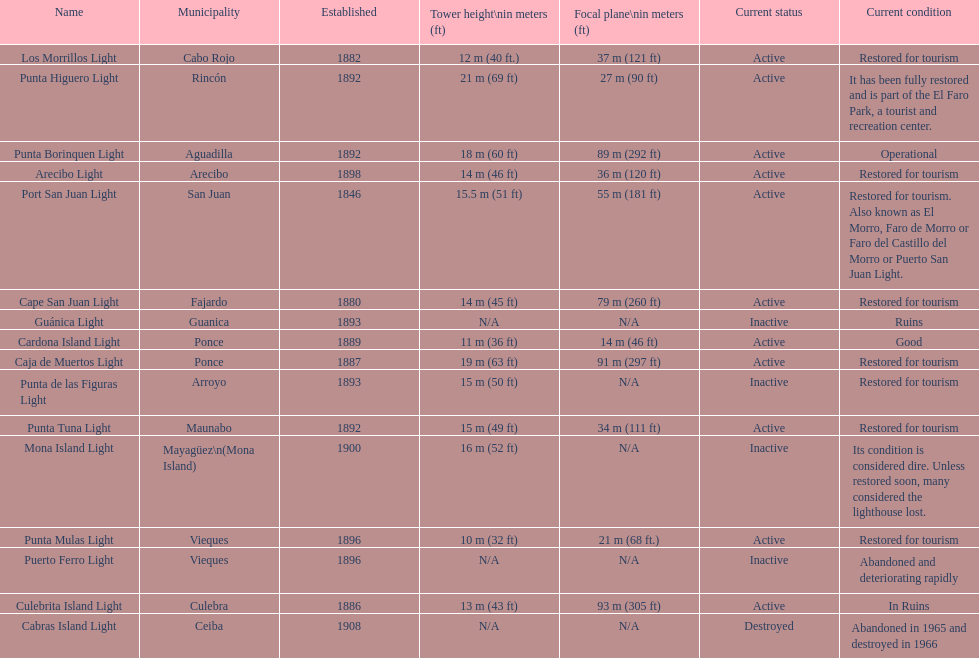How many years are there from 1882 to 1889? 7. 